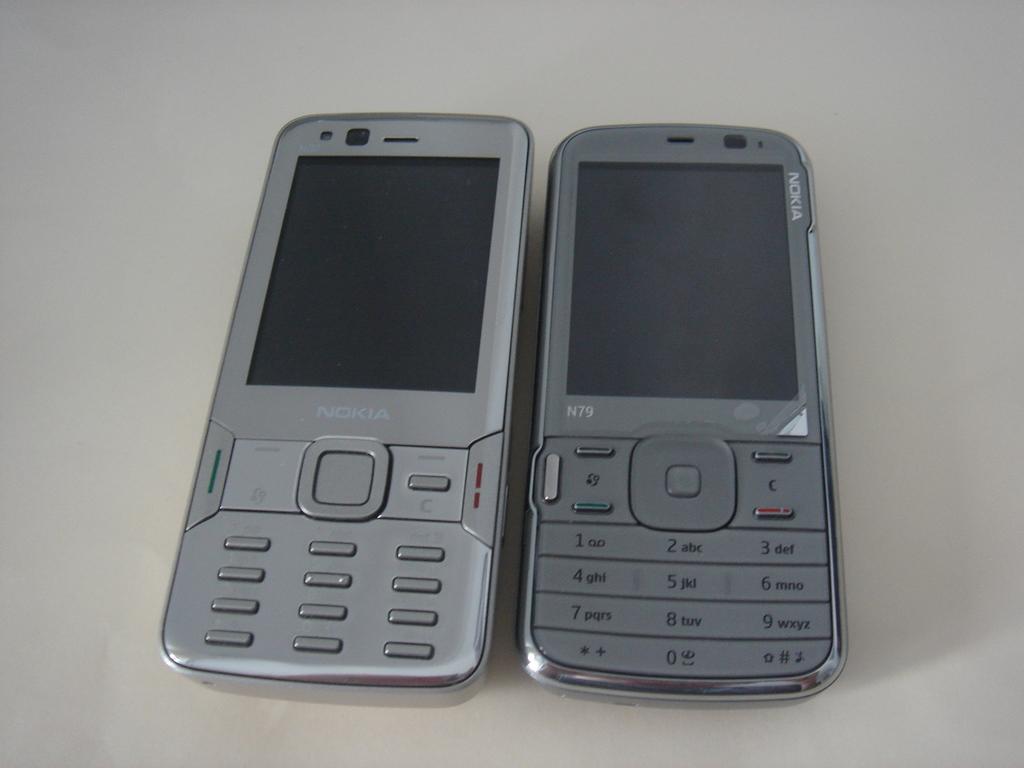What brand are these phones?
Provide a short and direct response. Nokia. What letters are on the 2 button?
Give a very brief answer. Abc. 